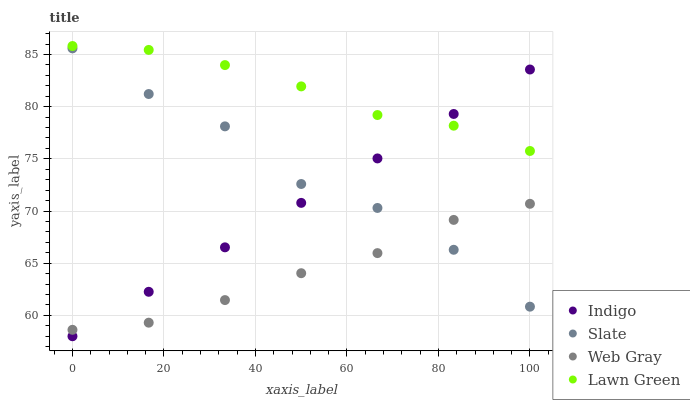Does Web Gray have the minimum area under the curve?
Answer yes or no. Yes. Does Lawn Green have the maximum area under the curve?
Answer yes or no. Yes. Does Slate have the minimum area under the curve?
Answer yes or no. No. Does Slate have the maximum area under the curve?
Answer yes or no. No. Is Indigo the smoothest?
Answer yes or no. Yes. Is Slate the roughest?
Answer yes or no. Yes. Is Web Gray the smoothest?
Answer yes or no. No. Is Web Gray the roughest?
Answer yes or no. No. Does Indigo have the lowest value?
Answer yes or no. Yes. Does Slate have the lowest value?
Answer yes or no. No. Does Lawn Green have the highest value?
Answer yes or no. Yes. Does Slate have the highest value?
Answer yes or no. No. Is Web Gray less than Lawn Green?
Answer yes or no. Yes. Is Lawn Green greater than Slate?
Answer yes or no. Yes. Does Indigo intersect Lawn Green?
Answer yes or no. Yes. Is Indigo less than Lawn Green?
Answer yes or no. No. Is Indigo greater than Lawn Green?
Answer yes or no. No. Does Web Gray intersect Lawn Green?
Answer yes or no. No. 